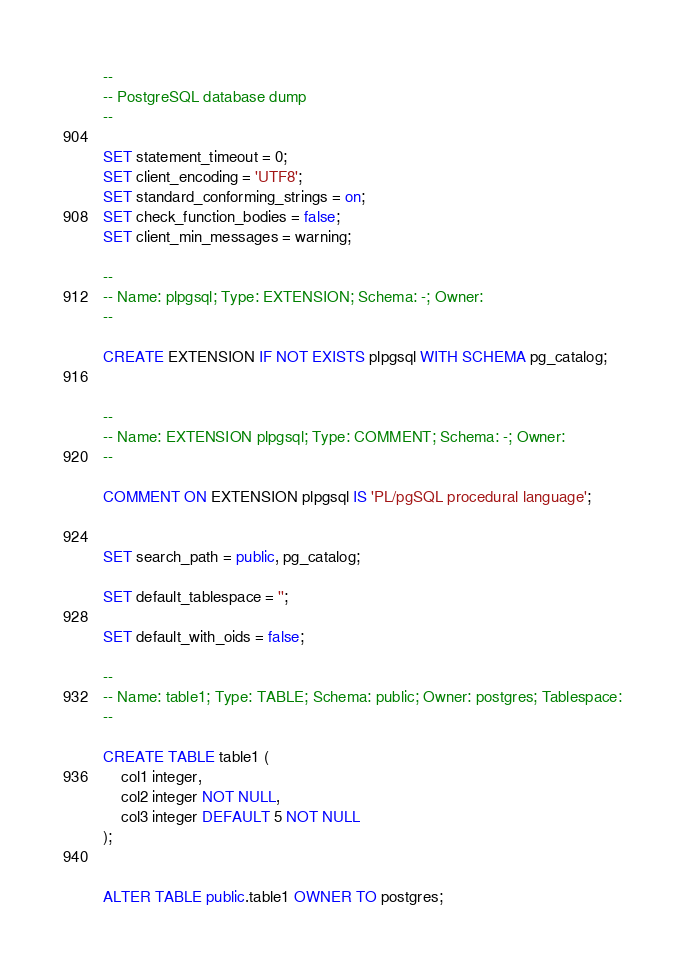Convert code to text. <code><loc_0><loc_0><loc_500><loc_500><_SQL_>--
-- PostgreSQL database dump
--

SET statement_timeout = 0;
SET client_encoding = 'UTF8';
SET standard_conforming_strings = on;
SET check_function_bodies = false;
SET client_min_messages = warning;

--
-- Name: plpgsql; Type: EXTENSION; Schema: -; Owner: 
--

CREATE EXTENSION IF NOT EXISTS plpgsql WITH SCHEMA pg_catalog;


--
-- Name: EXTENSION plpgsql; Type: COMMENT; Schema: -; Owner: 
--

COMMENT ON EXTENSION plpgsql IS 'PL/pgSQL procedural language';


SET search_path = public, pg_catalog;

SET default_tablespace = '';

SET default_with_oids = false;

--
-- Name: table1; Type: TABLE; Schema: public; Owner: postgres; Tablespace:
--

CREATE TABLE table1 (
    col1 integer,
    col2 integer NOT NULL,
    col3 integer DEFAULT 5 NOT NULL
);


ALTER TABLE public.table1 OWNER TO postgres;
</code> 